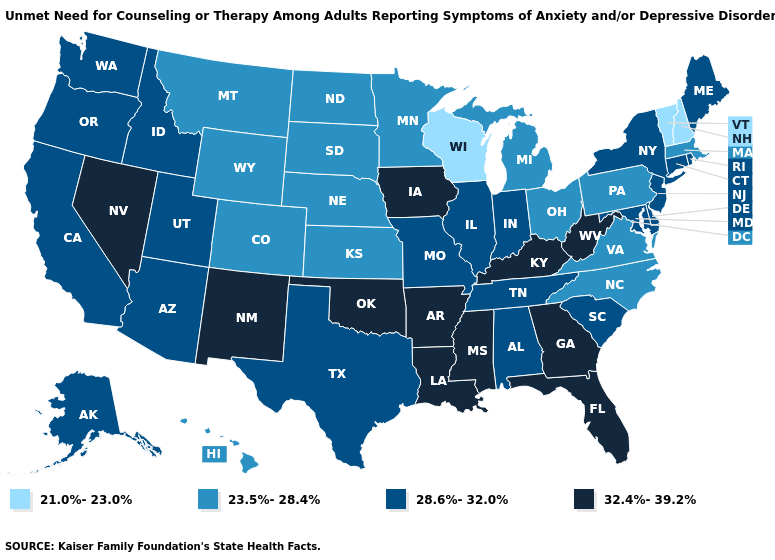What is the lowest value in states that border Massachusetts?
Give a very brief answer. 21.0%-23.0%. What is the value of Wisconsin?
Short answer required. 21.0%-23.0%. Name the states that have a value in the range 21.0%-23.0%?
Write a very short answer. New Hampshire, Vermont, Wisconsin. Among the states that border Kentucky , which have the lowest value?
Write a very short answer. Ohio, Virginia. Among the states that border Kentucky , does West Virginia have the highest value?
Answer briefly. Yes. What is the highest value in the MidWest ?
Write a very short answer. 32.4%-39.2%. What is the highest value in the South ?
Give a very brief answer. 32.4%-39.2%. What is the lowest value in the USA?
Short answer required. 21.0%-23.0%. What is the lowest value in the USA?
Keep it brief. 21.0%-23.0%. What is the value of Montana?
Concise answer only. 23.5%-28.4%. Which states have the lowest value in the West?
Be succinct. Colorado, Hawaii, Montana, Wyoming. What is the lowest value in the USA?
Give a very brief answer. 21.0%-23.0%. What is the highest value in the West ?
Answer briefly. 32.4%-39.2%. What is the value of Vermont?
Short answer required. 21.0%-23.0%. Among the states that border Georgia , does Florida have the highest value?
Be succinct. Yes. 